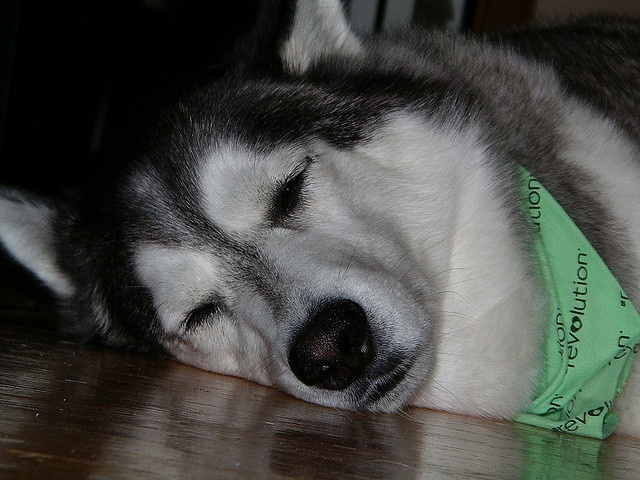Describe the objects in this image and their specific colors. I can see a dog in black, darkgray, gray, and teal tones in this image. 